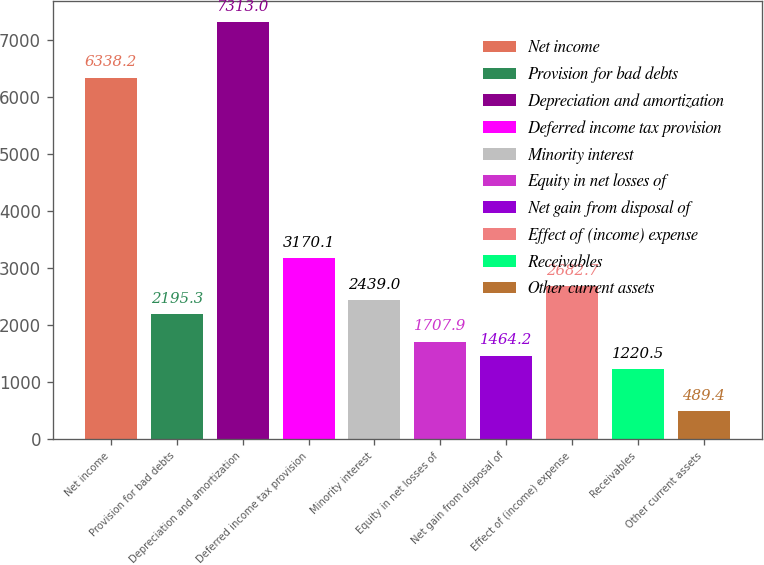Convert chart. <chart><loc_0><loc_0><loc_500><loc_500><bar_chart><fcel>Net income<fcel>Provision for bad debts<fcel>Depreciation and amortization<fcel>Deferred income tax provision<fcel>Minority interest<fcel>Equity in net losses of<fcel>Net gain from disposal of<fcel>Effect of (income) expense<fcel>Receivables<fcel>Other current assets<nl><fcel>6338.2<fcel>2195.3<fcel>7313<fcel>3170.1<fcel>2439<fcel>1707.9<fcel>1464.2<fcel>2682.7<fcel>1220.5<fcel>489.4<nl></chart> 